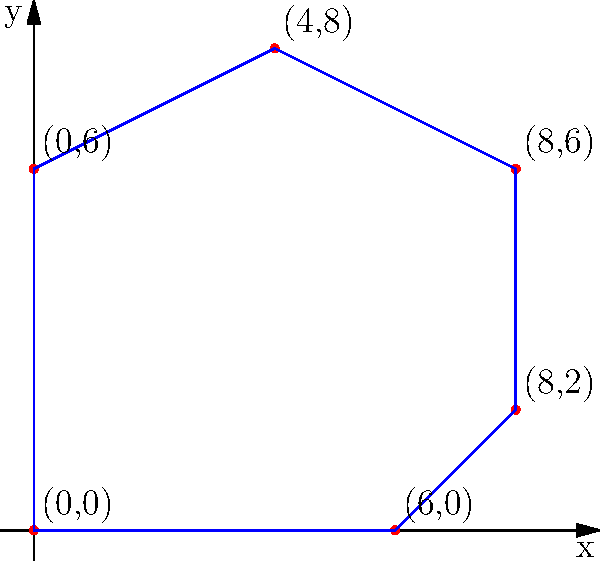A historical aircraft restoration project requires a specially designed hangar. The blueprint for the hangar is represented as a polygon on a coordinate plane, with vertices at (0,0), (6,0), (8,2), (8,6), (4,8), and (0,6). Calculate the area of this hangar in square units. To find the area of this irregular polygon, we can use the Shoelace formula (also known as the surveyor's formula). The steps are as follows:

1) List the coordinates in order (either clockwise or counterclockwise):
   (0,0), (6,0), (8,2), (8,6), (4,8), (0,6)

2) Apply the Shoelace formula:
   Area = $\frac{1}{2}|((x_1y_2 + x_2y_3 + ... + x_ny_1) - (y_1x_2 + y_2x_3 + ... + y_nx_1))|$

3) Calculate each term:
   $(0 \cdot 0) + (6 \cdot 2) + (8 \cdot 6) + (8 \cdot 8) + (4 \cdot 6) + (0 \cdot 0) = 12 + 48 + 64 + 24 = 148$
   $(0 \cdot 6) + (0 \cdot 8) + (2 \cdot 8) + (6 \cdot 4) + (8 \cdot 0) + (6 \cdot 0) = 16 + 24 = 40$

4) Subtract and take the absolute value:
   $|148 - 40| = 108$

5) Divide by 2:
   $\frac{108}{2} = 54$

Therefore, the area of the hangar is 54 square units.
Answer: 54 square units 